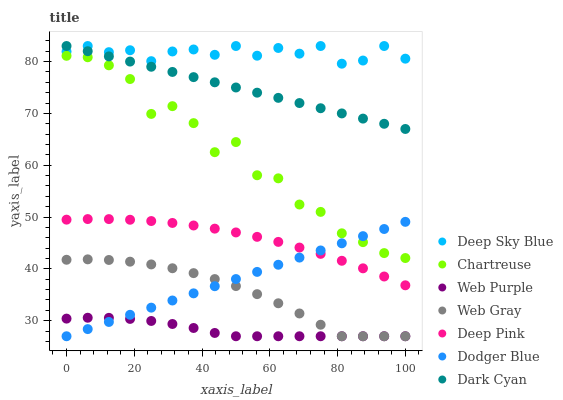Does Web Purple have the minimum area under the curve?
Answer yes or no. Yes. Does Deep Sky Blue have the maximum area under the curve?
Answer yes or no. Yes. Does Chartreuse have the minimum area under the curve?
Answer yes or no. No. Does Chartreuse have the maximum area under the curve?
Answer yes or no. No. Is Dark Cyan the smoothest?
Answer yes or no. Yes. Is Chartreuse the roughest?
Answer yes or no. Yes. Is Web Purple the smoothest?
Answer yes or no. No. Is Web Purple the roughest?
Answer yes or no. No. Does Web Gray have the lowest value?
Answer yes or no. Yes. Does Chartreuse have the lowest value?
Answer yes or no. No. Does Dark Cyan have the highest value?
Answer yes or no. Yes. Does Chartreuse have the highest value?
Answer yes or no. No. Is Chartreuse less than Dark Cyan?
Answer yes or no. Yes. Is Dark Cyan greater than Dodger Blue?
Answer yes or no. Yes. Does Dark Cyan intersect Deep Sky Blue?
Answer yes or no. Yes. Is Dark Cyan less than Deep Sky Blue?
Answer yes or no. No. Is Dark Cyan greater than Deep Sky Blue?
Answer yes or no. No. Does Chartreuse intersect Dark Cyan?
Answer yes or no. No. 